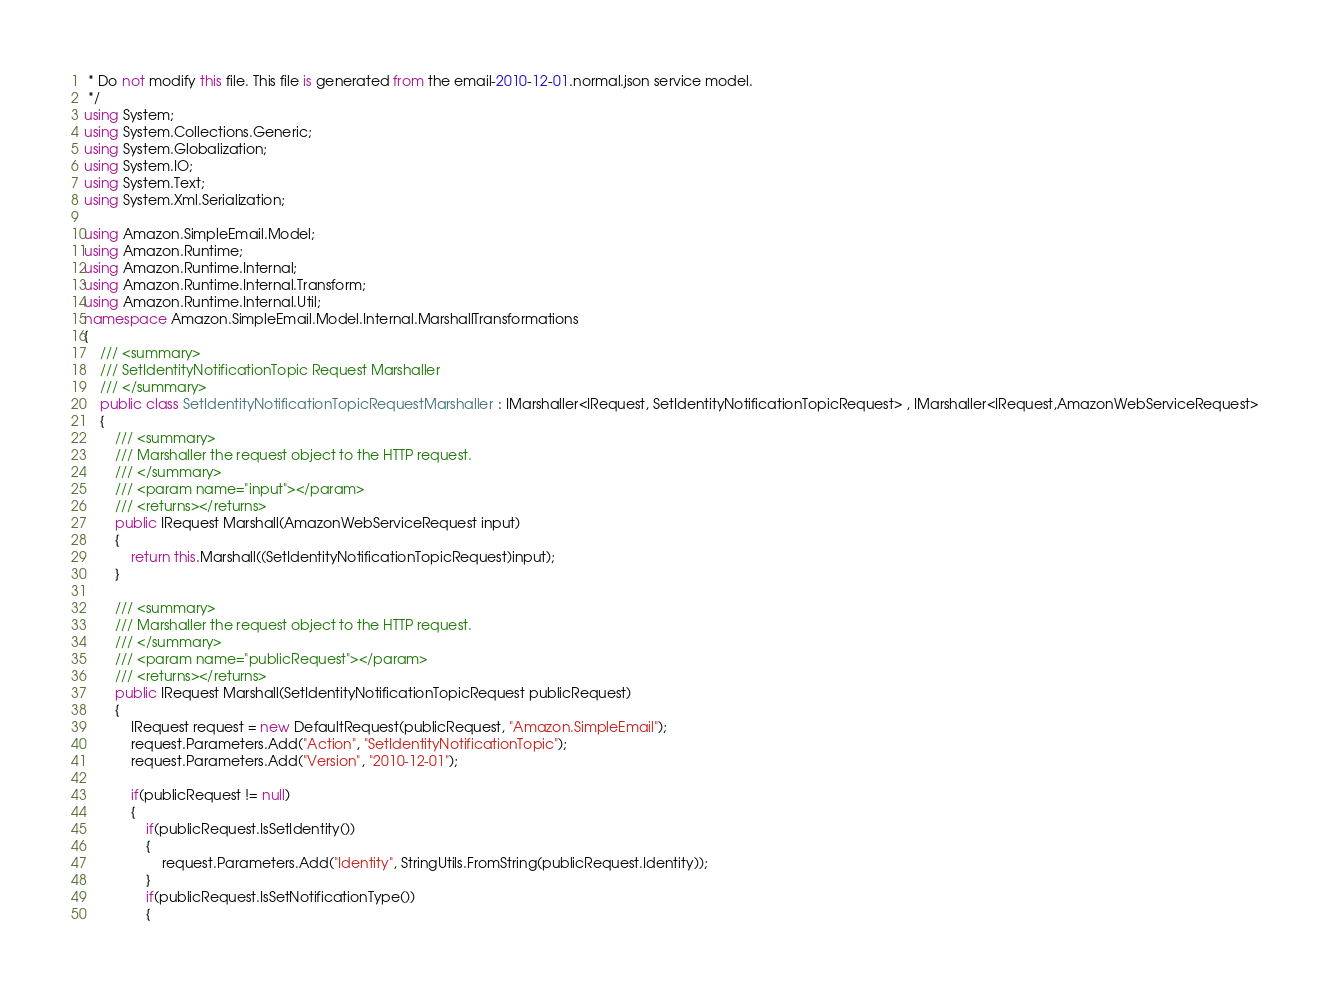Convert code to text. <code><loc_0><loc_0><loc_500><loc_500><_C#_> * Do not modify this file. This file is generated from the email-2010-12-01.normal.json service model.
 */
using System;
using System.Collections.Generic;
using System.Globalization;
using System.IO;
using System.Text;
using System.Xml.Serialization;

using Amazon.SimpleEmail.Model;
using Amazon.Runtime;
using Amazon.Runtime.Internal;
using Amazon.Runtime.Internal.Transform;
using Amazon.Runtime.Internal.Util;
namespace Amazon.SimpleEmail.Model.Internal.MarshallTransformations
{
    /// <summary>
    /// SetIdentityNotificationTopic Request Marshaller
    /// </summary>       
    public class SetIdentityNotificationTopicRequestMarshaller : IMarshaller<IRequest, SetIdentityNotificationTopicRequest> , IMarshaller<IRequest,AmazonWebServiceRequest>
    {
        /// <summary>
        /// Marshaller the request object to the HTTP request.
        /// </summary>  
        /// <param name="input"></param>
        /// <returns></returns>
        public IRequest Marshall(AmazonWebServiceRequest input)
        {
            return this.Marshall((SetIdentityNotificationTopicRequest)input);
        }
    
        /// <summary>
        /// Marshaller the request object to the HTTP request.
        /// </summary>  
        /// <param name="publicRequest"></param>
        /// <returns></returns>
        public IRequest Marshall(SetIdentityNotificationTopicRequest publicRequest)
        {
            IRequest request = new DefaultRequest(publicRequest, "Amazon.SimpleEmail");
            request.Parameters.Add("Action", "SetIdentityNotificationTopic");
            request.Parameters.Add("Version", "2010-12-01");

            if(publicRequest != null)
            {
                if(publicRequest.IsSetIdentity())
                {
                    request.Parameters.Add("Identity", StringUtils.FromString(publicRequest.Identity));
                }
                if(publicRequest.IsSetNotificationType())
                {</code> 